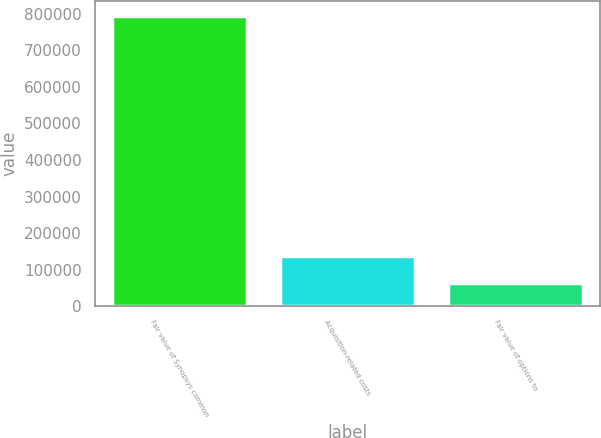<chart> <loc_0><loc_0><loc_500><loc_500><bar_chart><fcel>Fair value of Synopsys common<fcel>Acquisition-related costs<fcel>Fair value of options to<nl><fcel>795388<fcel>136268<fcel>63033<nl></chart> 